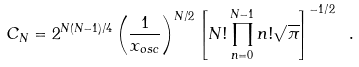Convert formula to latex. <formula><loc_0><loc_0><loc_500><loc_500>C _ { N } = 2 ^ { N ( N - 1 ) / 4 } \left ( \frac { 1 } { x _ { o s c } } \right ) ^ { N / 2 } \left [ N ! \prod _ { n = 0 } ^ { N - 1 } n ! \sqrt { \pi } \right ] ^ { - 1 / 2 } \ .</formula> 